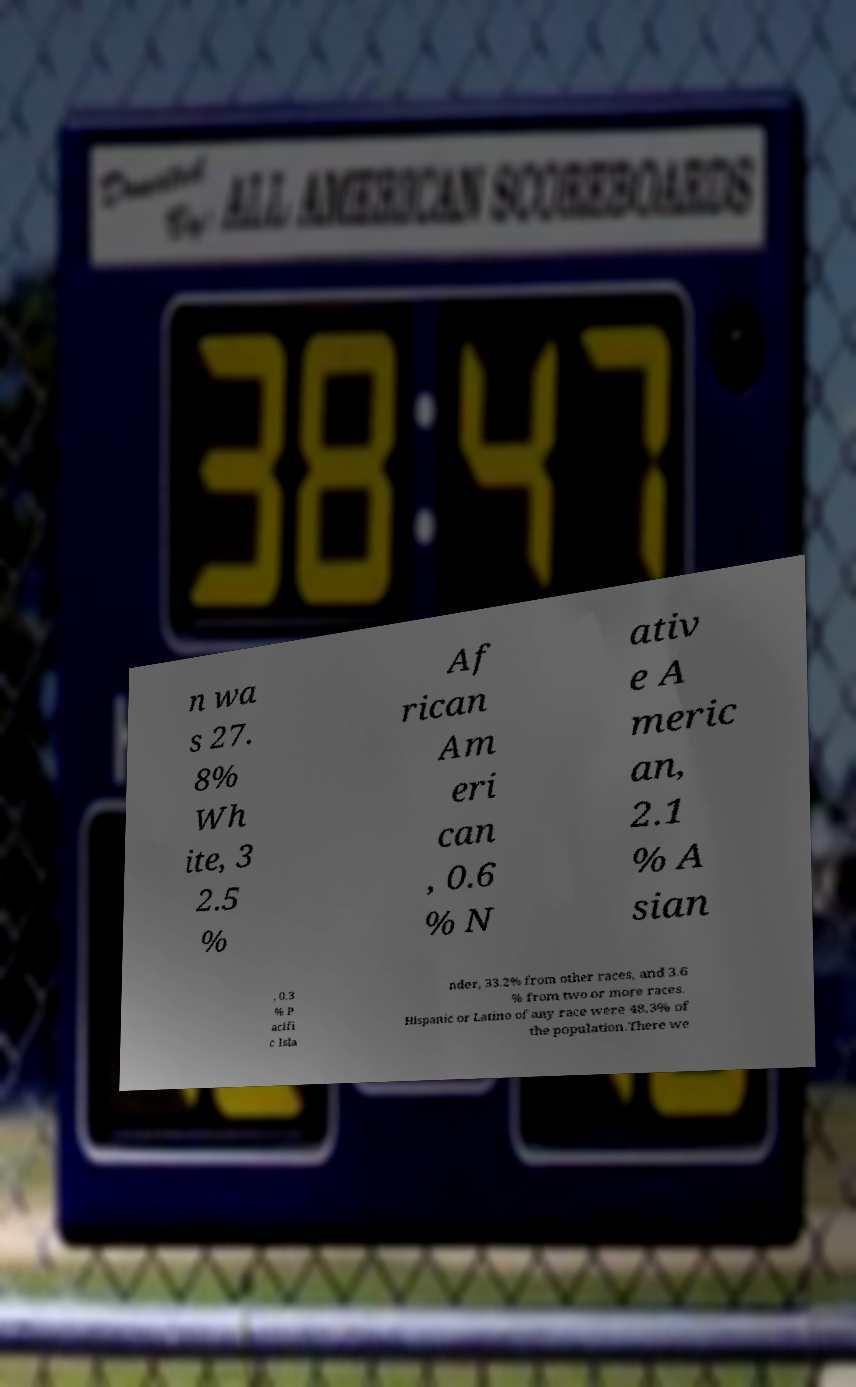Could you extract and type out the text from this image? n wa s 27. 8% Wh ite, 3 2.5 % Af rican Am eri can , 0.6 % N ativ e A meric an, 2.1 % A sian , 0.3 % P acifi c Isla nder, 33.2% from other races, and 3.6 % from two or more races. Hispanic or Latino of any race were 48.3% of the population.There we 